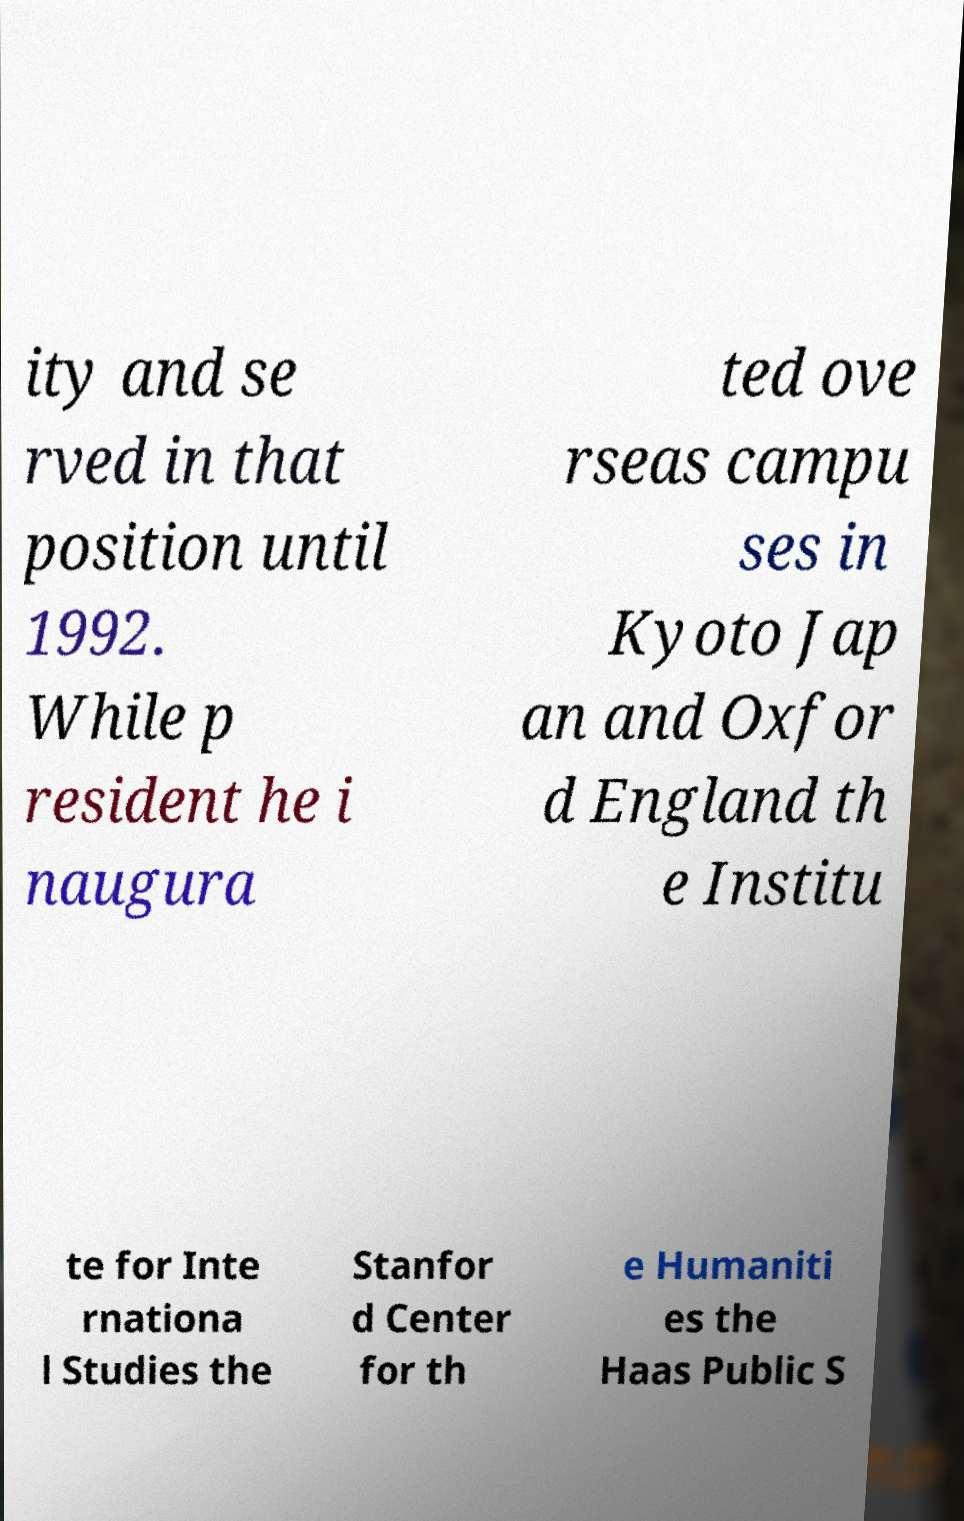Please identify and transcribe the text found in this image. ity and se rved in that position until 1992. While p resident he i naugura ted ove rseas campu ses in Kyoto Jap an and Oxfor d England th e Institu te for Inte rnationa l Studies the Stanfor d Center for th e Humaniti es the Haas Public S 